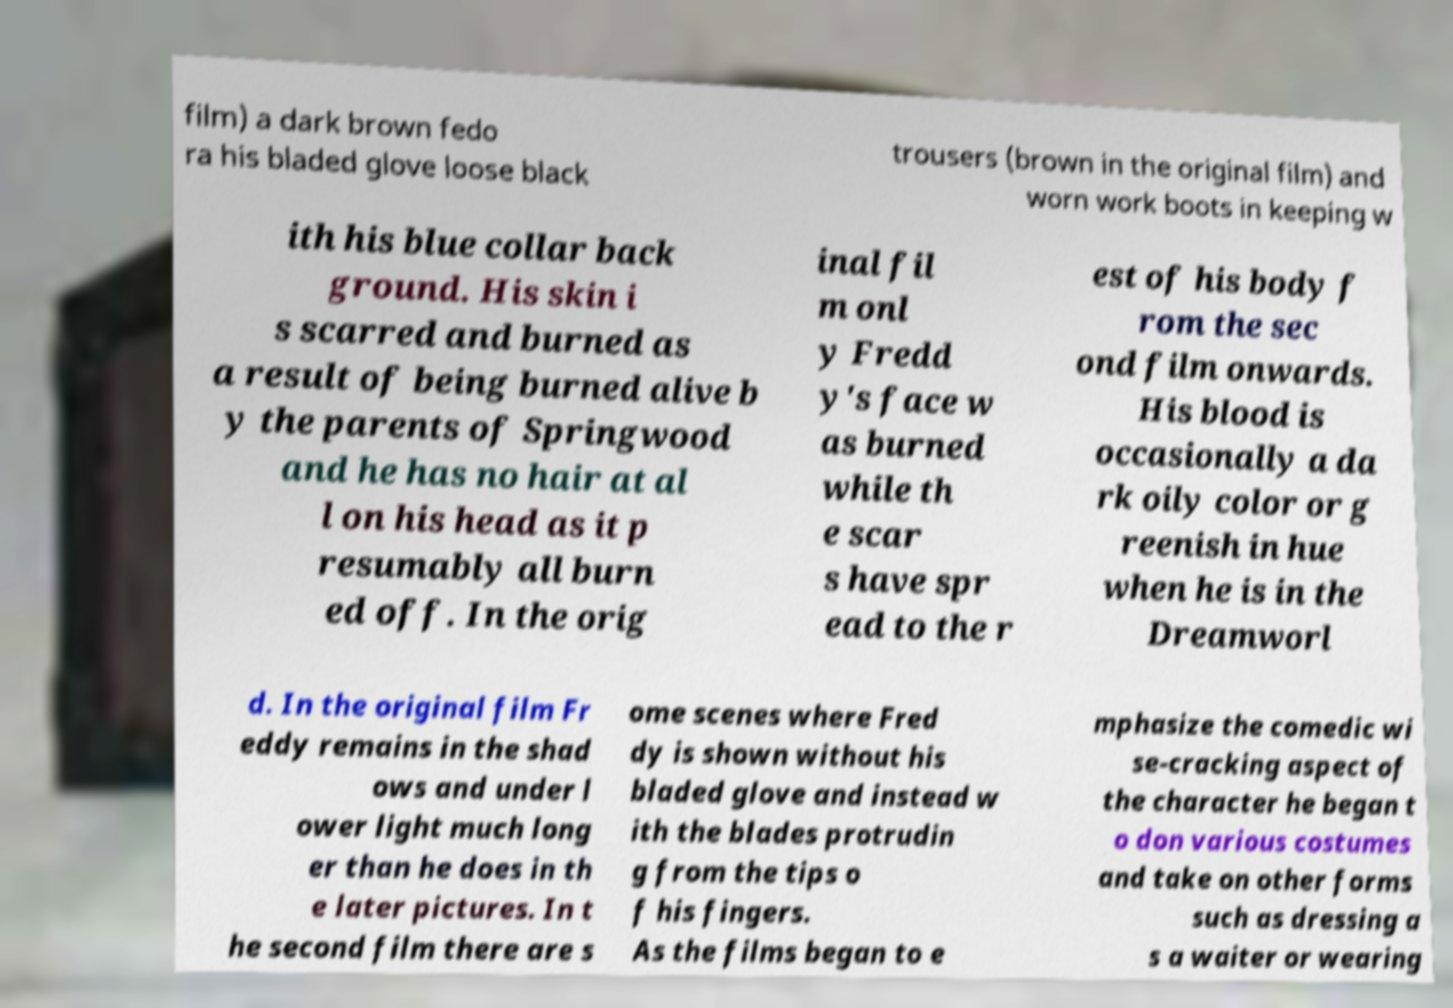Can you accurately transcribe the text from the provided image for me? film) a dark brown fedo ra his bladed glove loose black trousers (brown in the original film) and worn work boots in keeping w ith his blue collar back ground. His skin i s scarred and burned as a result of being burned alive b y the parents of Springwood and he has no hair at al l on his head as it p resumably all burn ed off. In the orig inal fil m onl y Fredd y's face w as burned while th e scar s have spr ead to the r est of his body f rom the sec ond film onwards. His blood is occasionally a da rk oily color or g reenish in hue when he is in the Dreamworl d. In the original film Fr eddy remains in the shad ows and under l ower light much long er than he does in th e later pictures. In t he second film there are s ome scenes where Fred dy is shown without his bladed glove and instead w ith the blades protrudin g from the tips o f his fingers. As the films began to e mphasize the comedic wi se-cracking aspect of the character he began t o don various costumes and take on other forms such as dressing a s a waiter or wearing 